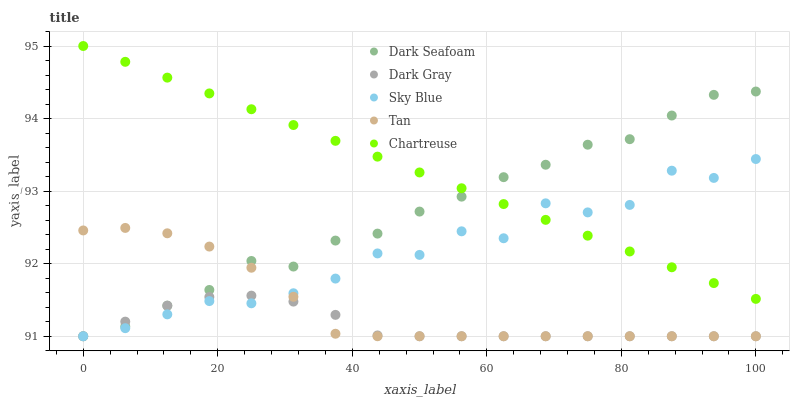Does Dark Gray have the minimum area under the curve?
Answer yes or no. Yes. Does Chartreuse have the maximum area under the curve?
Answer yes or no. Yes. Does Sky Blue have the minimum area under the curve?
Answer yes or no. No. Does Sky Blue have the maximum area under the curve?
Answer yes or no. No. Is Chartreuse the smoothest?
Answer yes or no. Yes. Is Sky Blue the roughest?
Answer yes or no. Yes. Is Dark Seafoam the smoothest?
Answer yes or no. No. Is Dark Seafoam the roughest?
Answer yes or no. No. Does Dark Gray have the lowest value?
Answer yes or no. Yes. Does Chartreuse have the lowest value?
Answer yes or no. No. Does Chartreuse have the highest value?
Answer yes or no. Yes. Does Sky Blue have the highest value?
Answer yes or no. No. Is Dark Gray less than Chartreuse?
Answer yes or no. Yes. Is Chartreuse greater than Tan?
Answer yes or no. Yes. Does Sky Blue intersect Dark Gray?
Answer yes or no. Yes. Is Sky Blue less than Dark Gray?
Answer yes or no. No. Is Sky Blue greater than Dark Gray?
Answer yes or no. No. Does Dark Gray intersect Chartreuse?
Answer yes or no. No. 